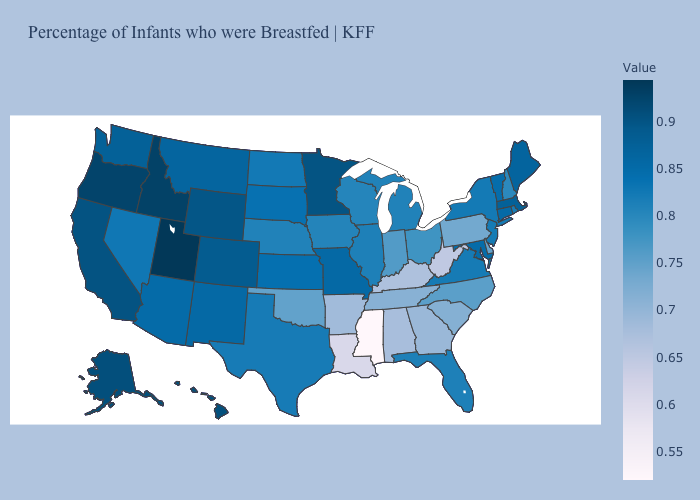Does Utah have the highest value in the USA?
Be succinct. Yes. Among the states that border Washington , does Idaho have the lowest value?
Quick response, please. No. Does Arkansas have a lower value than Montana?
Keep it brief. Yes. Among the states that border Rhode Island , does Massachusetts have the lowest value?
Give a very brief answer. No. Does Connecticut have a lower value than Alabama?
Short answer required. No. Does North Carolina have the lowest value in the USA?
Short answer required. No. 